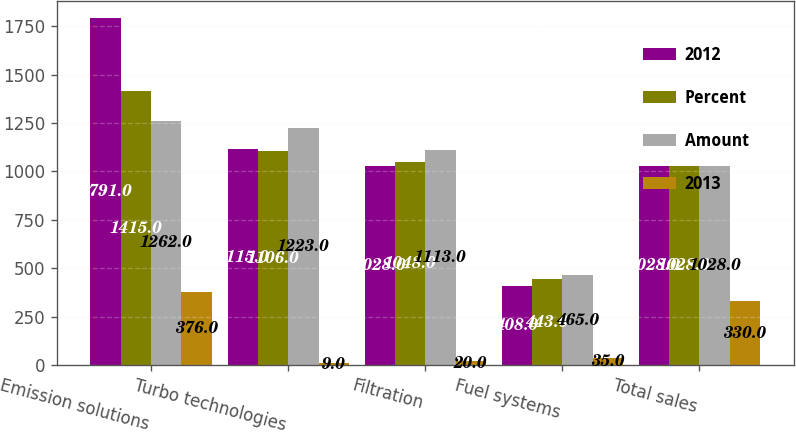Convert chart to OTSL. <chart><loc_0><loc_0><loc_500><loc_500><stacked_bar_chart><ecel><fcel>Emission solutions<fcel>Turbo technologies<fcel>Filtration<fcel>Fuel systems<fcel>Total sales<nl><fcel>2012<fcel>1791<fcel>1115<fcel>1028<fcel>408<fcel>1028<nl><fcel>Percent<fcel>1415<fcel>1106<fcel>1048<fcel>443<fcel>1028<nl><fcel>Amount<fcel>1262<fcel>1223<fcel>1113<fcel>465<fcel>1028<nl><fcel>2013<fcel>376<fcel>9<fcel>20<fcel>35<fcel>330<nl></chart> 